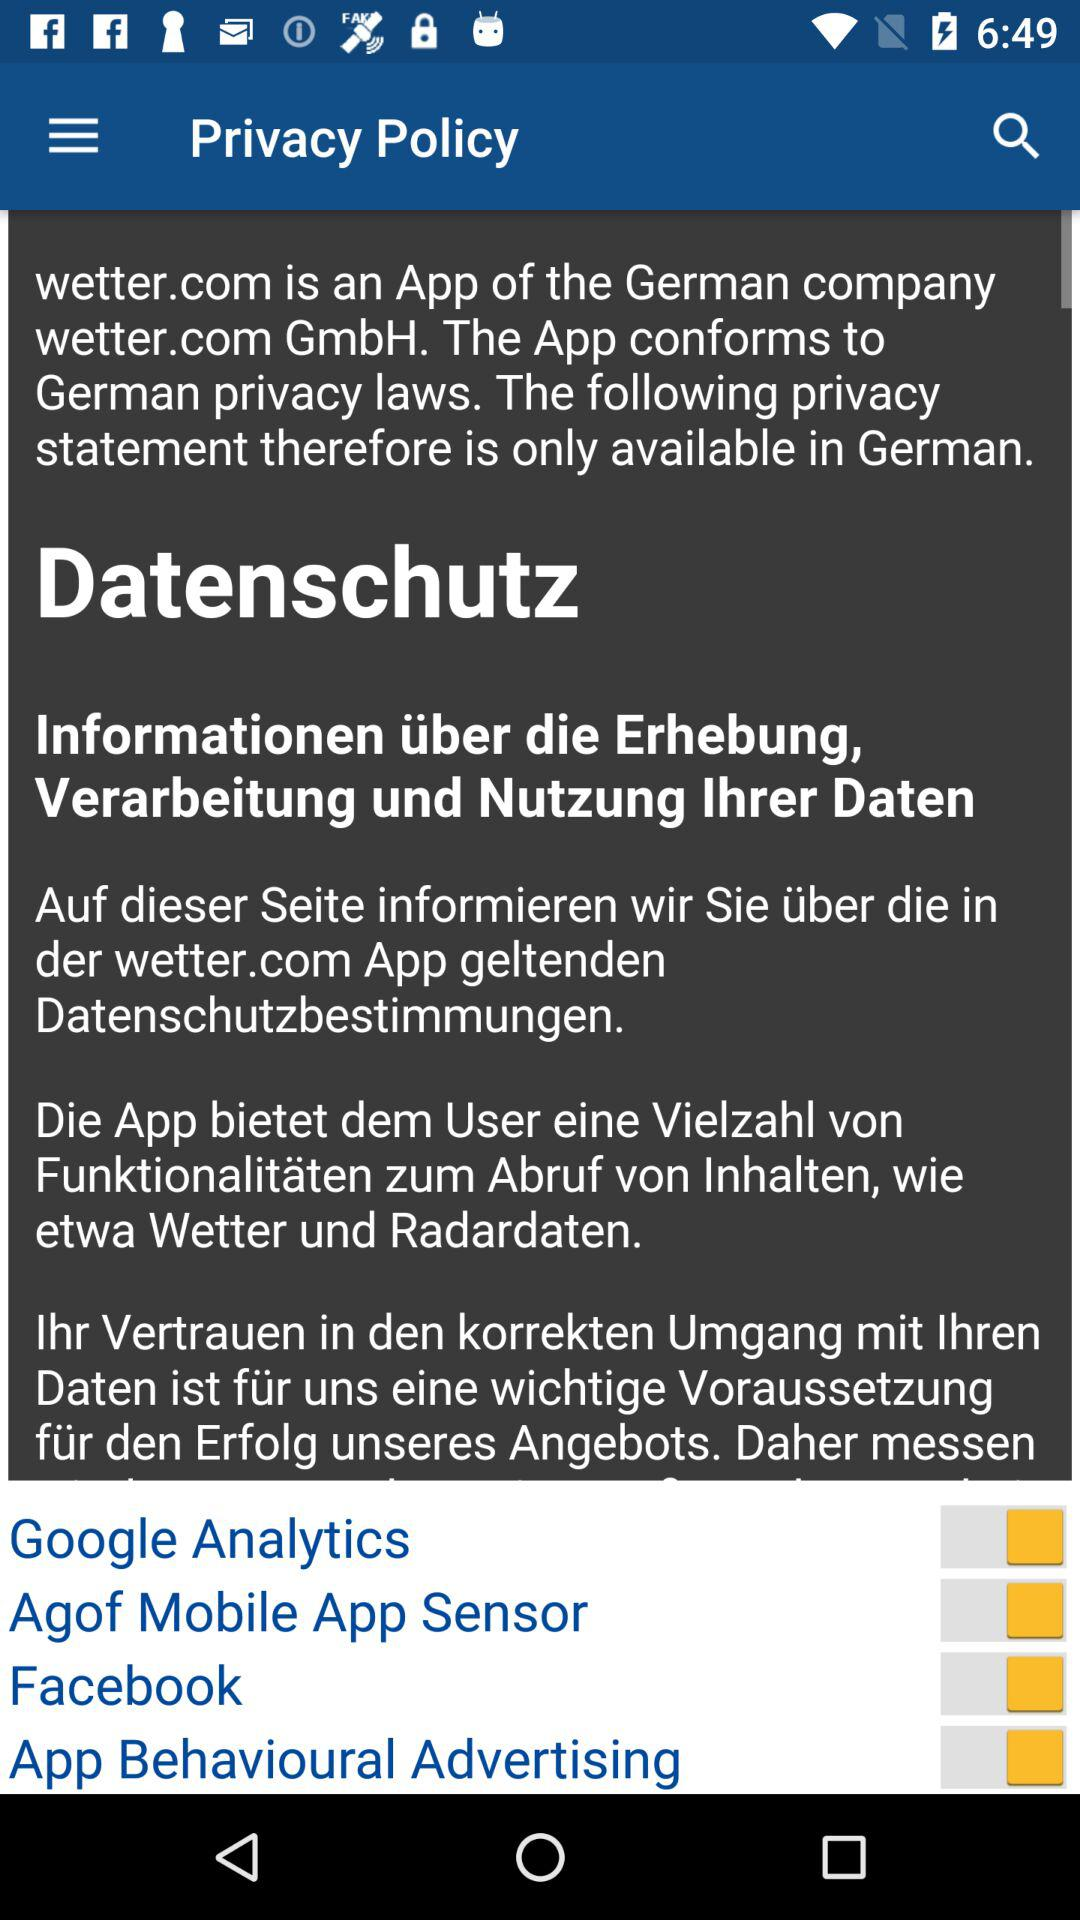What is the name of the application? The name of the application is "wetter.com". 